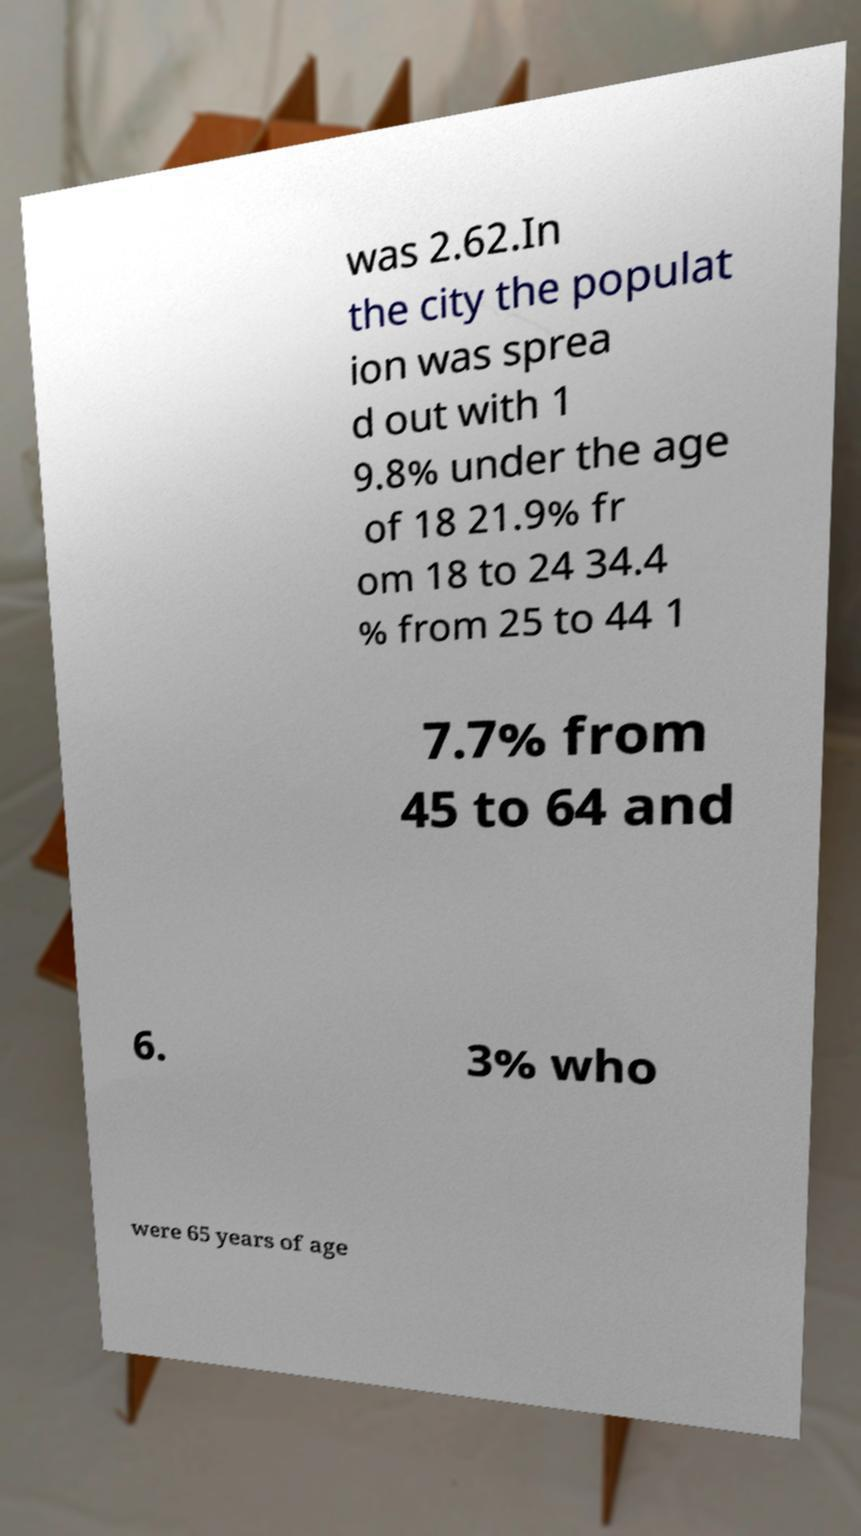Please read and relay the text visible in this image. What does it say? was 2.62.In the city the populat ion was sprea d out with 1 9.8% under the age of 18 21.9% fr om 18 to 24 34.4 % from 25 to 44 1 7.7% from 45 to 64 and 6. 3% who were 65 years of age 